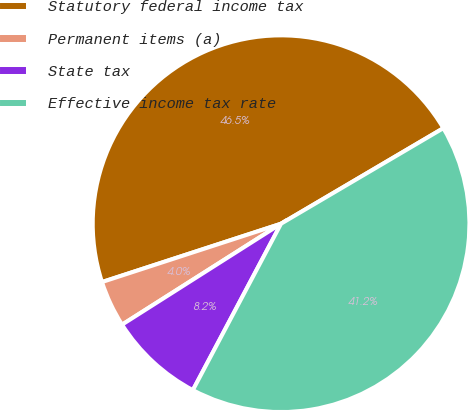Convert chart to OTSL. <chart><loc_0><loc_0><loc_500><loc_500><pie_chart><fcel>Statutory federal income tax<fcel>Permanent items (a)<fcel>State tax<fcel>Effective income tax rate<nl><fcel>46.54%<fcel>3.99%<fcel>8.24%<fcel>41.22%<nl></chart> 